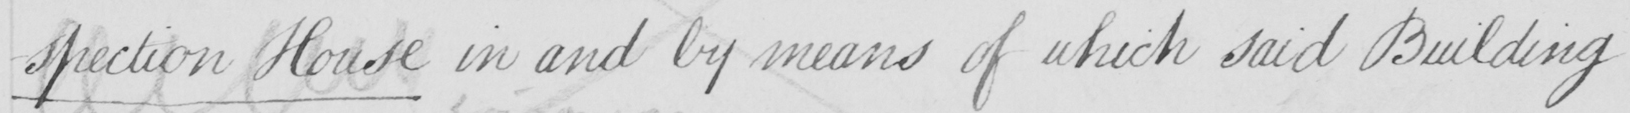Can you tell me what this handwritten text says? -spection House in and by means of which said Building 